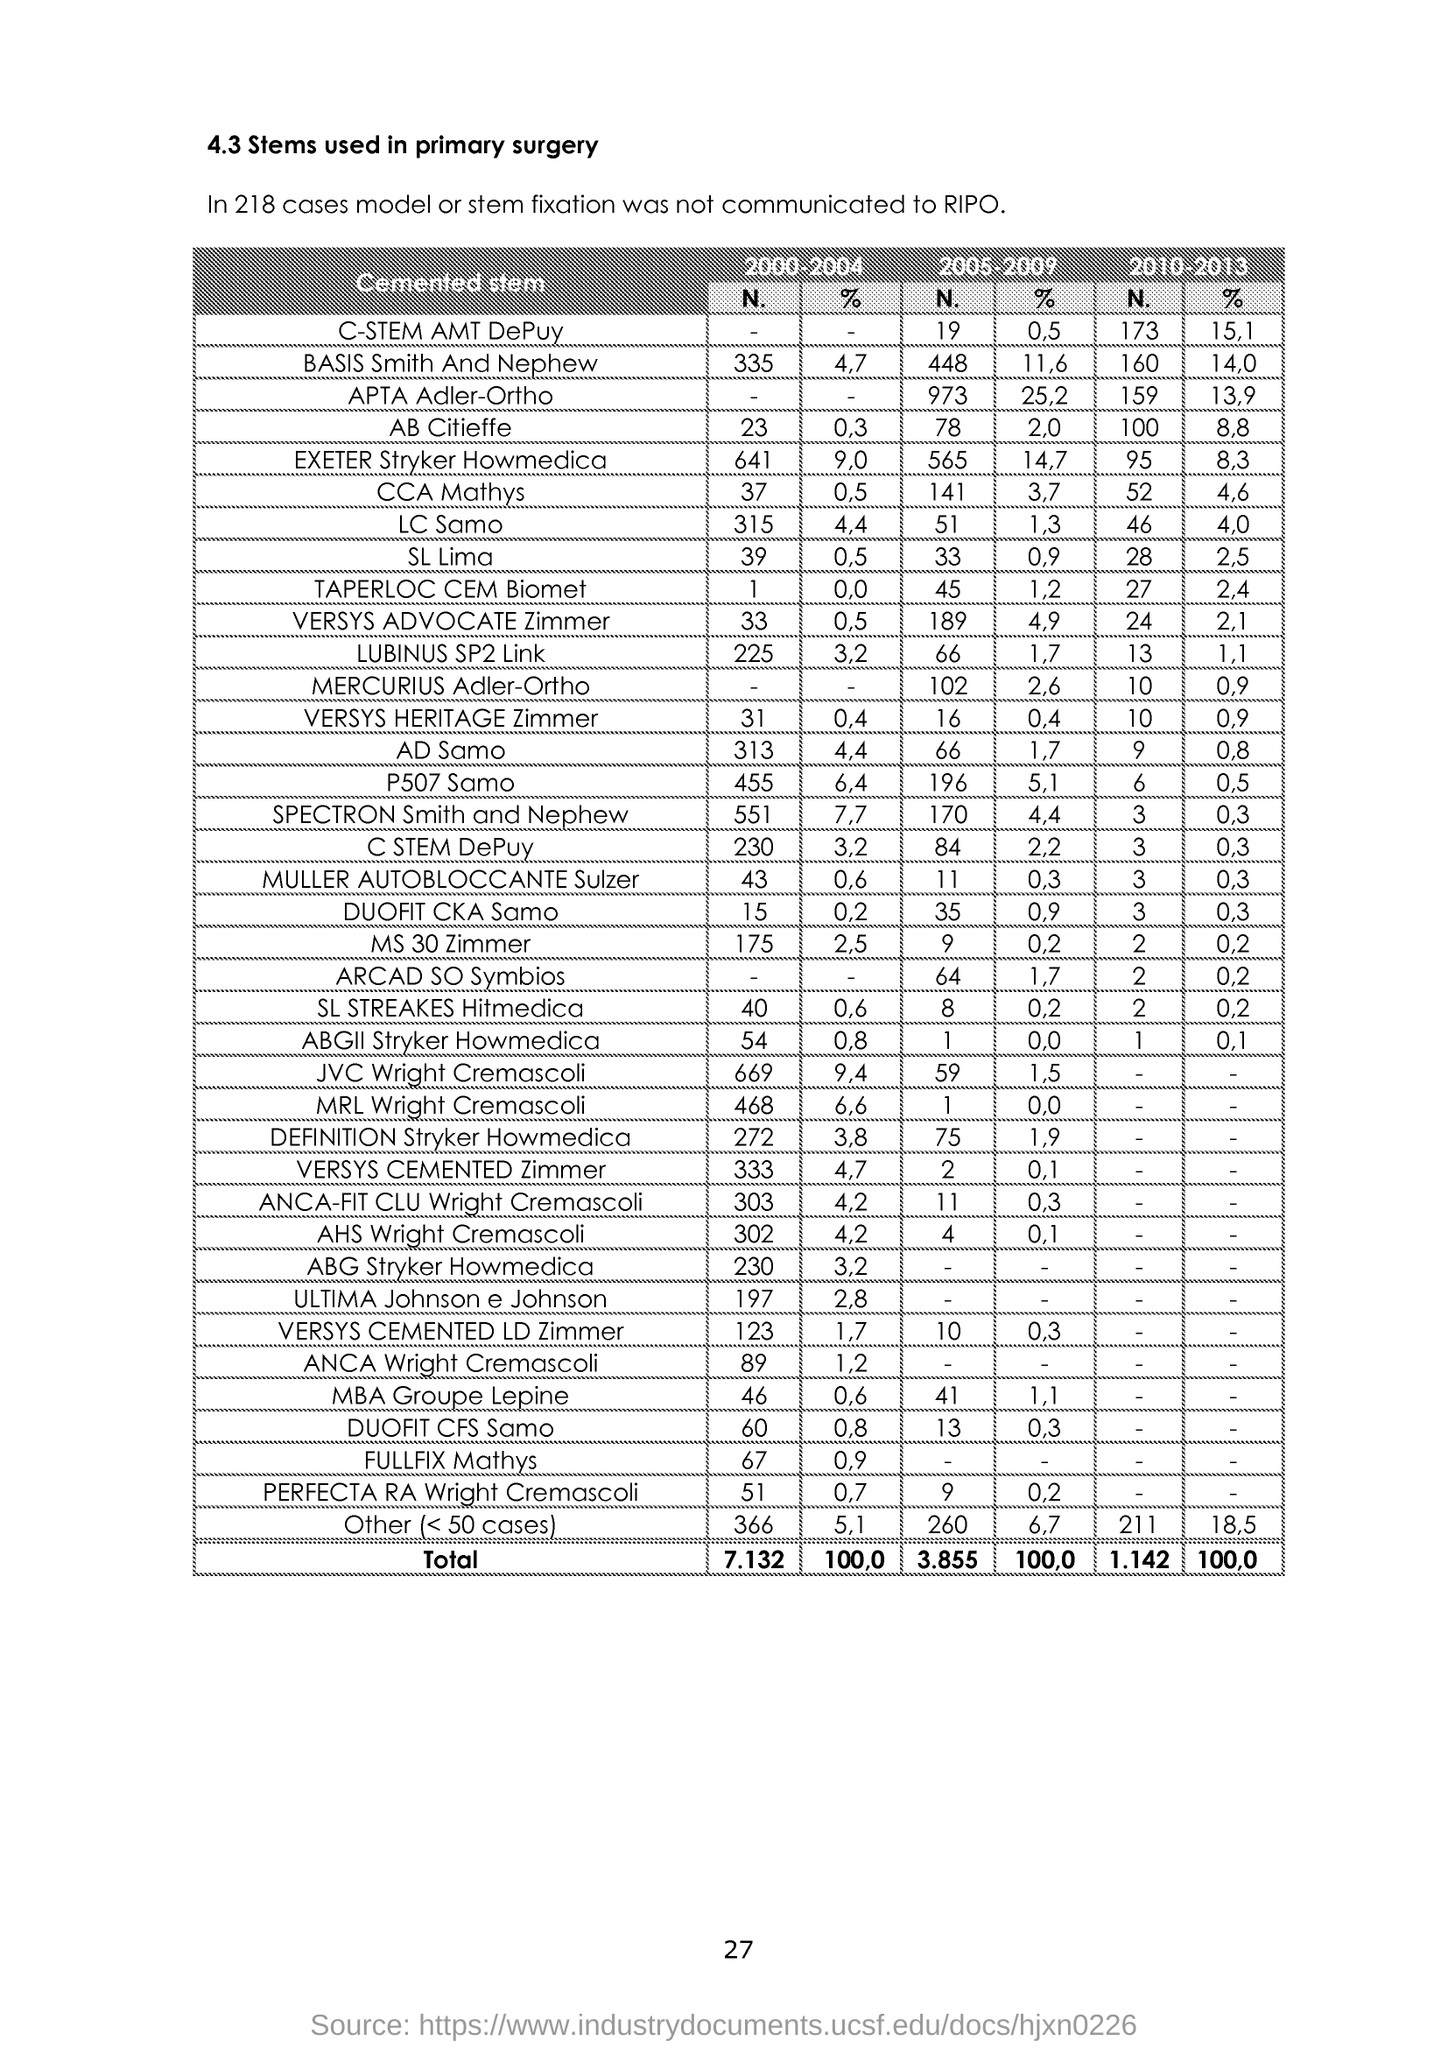What is the Page Number?
Keep it short and to the point. 27. What is the number of "Versys Cemented Zimmer" in the year 2000-2004?
Your answer should be very brief. 333. What is the number of "Versys Cemented LD Zimmer" in the year 2005-2009?
Provide a succinct answer. 10. What is the percentage of "CCA Mathys" in the year 2010-2013?
Keep it short and to the point. 4,6. What is the percentage of "MS 30 Zimmer" in the year 2000-2004?
Give a very brief answer. 2,5. What is the number of "Lubinus SP2 Link" in the year 2000-2004?
Provide a succinct answer. 225. What is the number of "Fullfix Mathys" in the year 2000-2004?
Give a very brief answer. 67. 